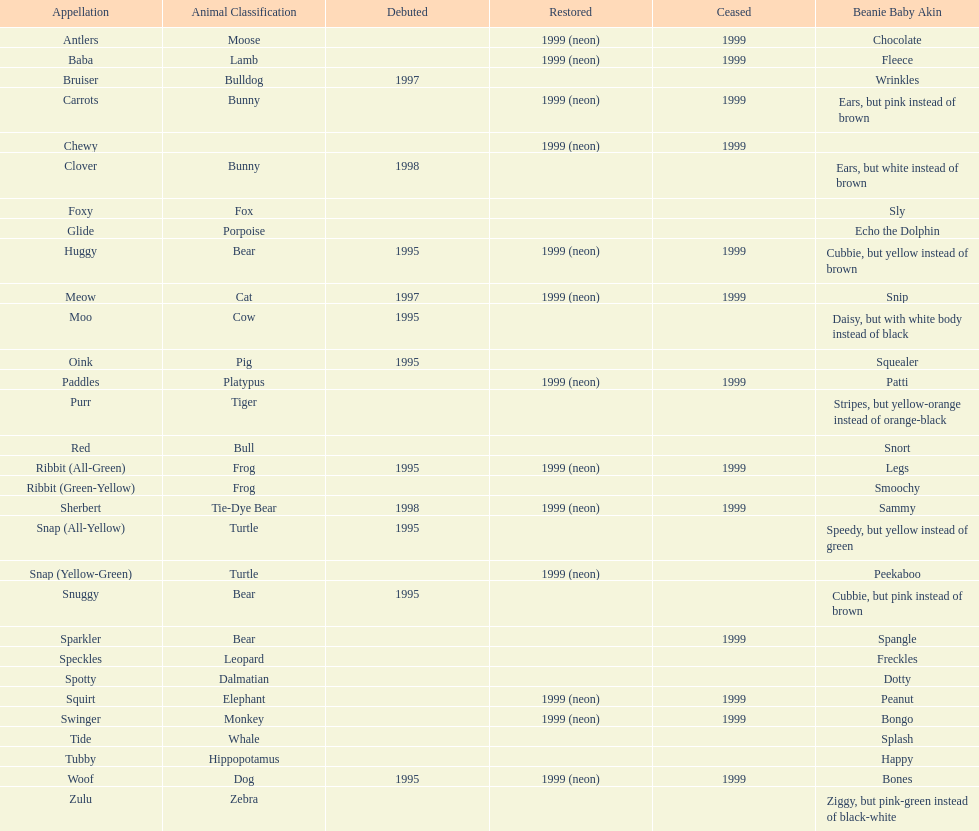How many total pillow pals were both reintroduced and retired in 1999? 12. Write the full table. {'header': ['Appellation', 'Animal Classification', 'Debuted', 'Restored', 'Ceased', 'Beanie Baby Akin'], 'rows': [['Antlers', 'Moose', '', '1999 (neon)', '1999', 'Chocolate'], ['Baba', 'Lamb', '', '1999 (neon)', '1999', 'Fleece'], ['Bruiser', 'Bulldog', '1997', '', '', 'Wrinkles'], ['Carrots', 'Bunny', '', '1999 (neon)', '1999', 'Ears, but pink instead of brown'], ['Chewy', '', '', '1999 (neon)', '1999', ''], ['Clover', 'Bunny', '1998', '', '', 'Ears, but white instead of brown'], ['Foxy', 'Fox', '', '', '', 'Sly'], ['Glide', 'Porpoise', '', '', '', 'Echo the Dolphin'], ['Huggy', 'Bear', '1995', '1999 (neon)', '1999', 'Cubbie, but yellow instead of brown'], ['Meow', 'Cat', '1997', '1999 (neon)', '1999', 'Snip'], ['Moo', 'Cow', '1995', '', '', 'Daisy, but with white body instead of black'], ['Oink', 'Pig', '1995', '', '', 'Squealer'], ['Paddles', 'Platypus', '', '1999 (neon)', '1999', 'Patti'], ['Purr', 'Tiger', '', '', '', 'Stripes, but yellow-orange instead of orange-black'], ['Red', 'Bull', '', '', '', 'Snort'], ['Ribbit (All-Green)', 'Frog', '1995', '1999 (neon)', '1999', 'Legs'], ['Ribbit (Green-Yellow)', 'Frog', '', '', '', 'Smoochy'], ['Sherbert', 'Tie-Dye Bear', '1998', '1999 (neon)', '1999', 'Sammy'], ['Snap (All-Yellow)', 'Turtle', '1995', '', '', 'Speedy, but yellow instead of green'], ['Snap (Yellow-Green)', 'Turtle', '', '1999 (neon)', '', 'Peekaboo'], ['Snuggy', 'Bear', '1995', '', '', 'Cubbie, but pink instead of brown'], ['Sparkler', 'Bear', '', '', '1999', 'Spangle'], ['Speckles', 'Leopard', '', '', '', 'Freckles'], ['Spotty', 'Dalmatian', '', '', '', 'Dotty'], ['Squirt', 'Elephant', '', '1999 (neon)', '1999', 'Peanut'], ['Swinger', 'Monkey', '', '1999 (neon)', '1999', 'Bongo'], ['Tide', 'Whale', '', '', '', 'Splash'], ['Tubby', 'Hippopotamus', '', '', '', 'Happy'], ['Woof', 'Dog', '1995', '1999 (neon)', '1999', 'Bones'], ['Zulu', 'Zebra', '', '', '', 'Ziggy, but pink-green instead of black-white']]} 